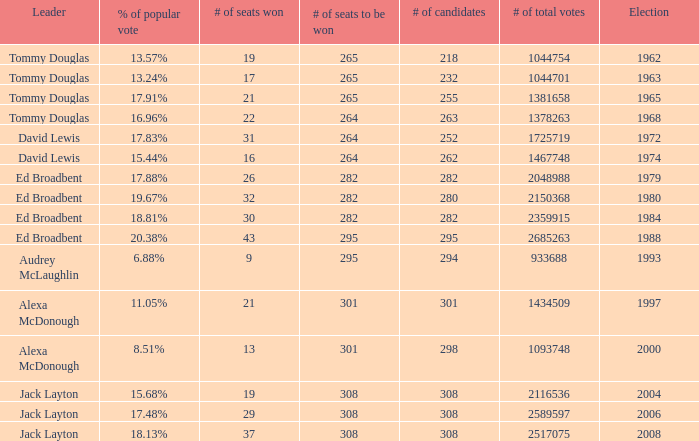Name the number of candidates for # of seats won being 43 295.0. Can you parse all the data within this table? {'header': ['Leader', '% of popular vote', '# of seats won', '# of seats to be won', '# of candidates', '# of total votes', 'Election'], 'rows': [['Tommy Douglas', '13.57%', '19', '265', '218', '1044754', '1962'], ['Tommy Douglas', '13.24%', '17', '265', '232', '1044701', '1963'], ['Tommy Douglas', '17.91%', '21', '265', '255', '1381658', '1965'], ['Tommy Douglas', '16.96%', '22', '264', '263', '1378263', '1968'], ['David Lewis', '17.83%', '31', '264', '252', '1725719', '1972'], ['David Lewis', '15.44%', '16', '264', '262', '1467748', '1974'], ['Ed Broadbent', '17.88%', '26', '282', '282', '2048988', '1979'], ['Ed Broadbent', '19.67%', '32', '282', '280', '2150368', '1980'], ['Ed Broadbent', '18.81%', '30', '282', '282', '2359915', '1984'], ['Ed Broadbent', '20.38%', '43', '295', '295', '2685263', '1988'], ['Audrey McLaughlin', '6.88%', '9', '295', '294', '933688', '1993'], ['Alexa McDonough', '11.05%', '21', '301', '301', '1434509', '1997'], ['Alexa McDonough', '8.51%', '13', '301', '298', '1093748', '2000'], ['Jack Layton', '15.68%', '19', '308', '308', '2116536', '2004'], ['Jack Layton', '17.48%', '29', '308', '308', '2589597', '2006'], ['Jack Layton', '18.13%', '37', '308', '308', '2517075', '2008']]} 